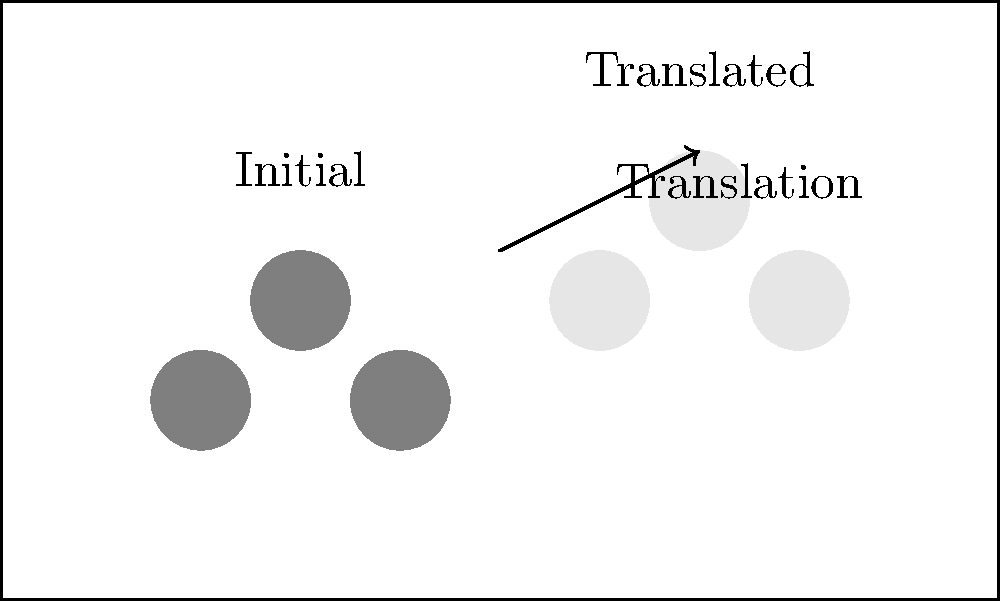In a stage diagram, three actor silhouettes are represented by circles at initial positions (2,2), (3,3), and (4,2). The director wants to translate all actors by the vector $\langle 4, 1 \rangle$. What will be the new position of the actor who was initially at (3,3)? To solve this problem, we need to apply the translation vector to the initial position of the actor in question. Here's the step-by-step process:

1. Identify the initial position of the actor: (3,3)
2. Identify the translation vector: $\langle 4, 1 \rangle$
3. Apply the translation by adding the vector components to the initial coordinates:
   - New x-coordinate: $3 + 4 = 7$
   - New y-coordinate: $3 + 1 = 4$
4. Combine the new coordinates to get the final position: (7,4)

The translation moves the actor 4 units to the right and 1 unit up from their initial position.
Answer: (7,4) 